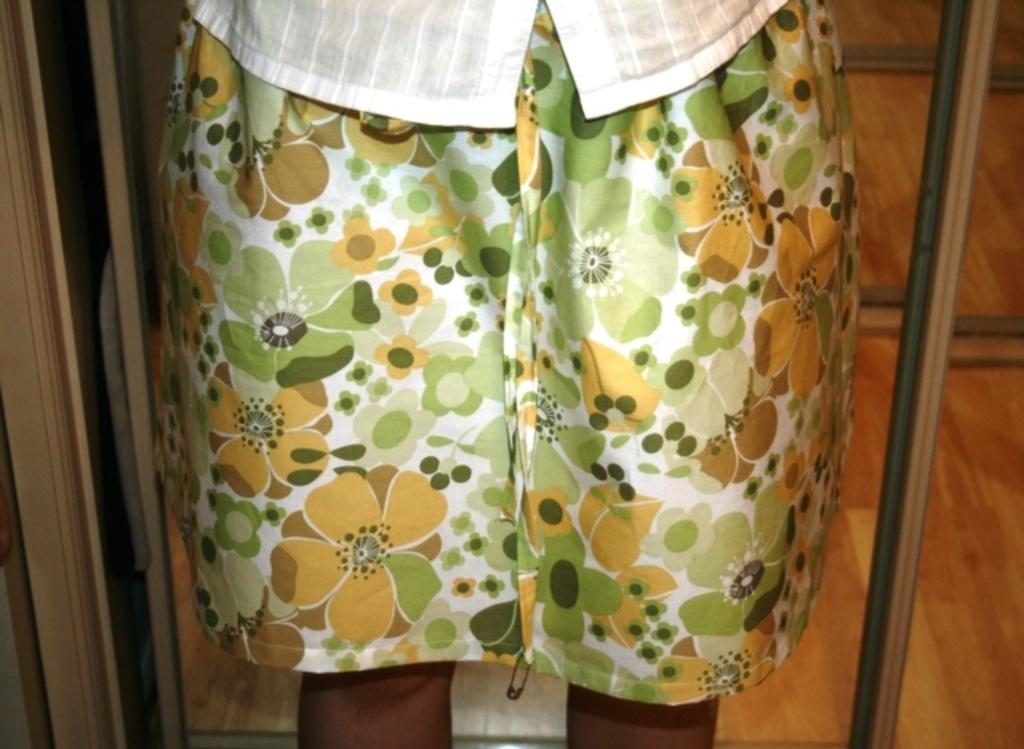Who or what is in the front of the image? There is a person in the front of the image. What type of flooring is visible at the bottom of the image? There is a wooden floor at the bottom of the image. What type of spark can be seen coming from the person's hand in the image? There is no spark visible in the image; the person's hand is not shown emitting any sparks. 